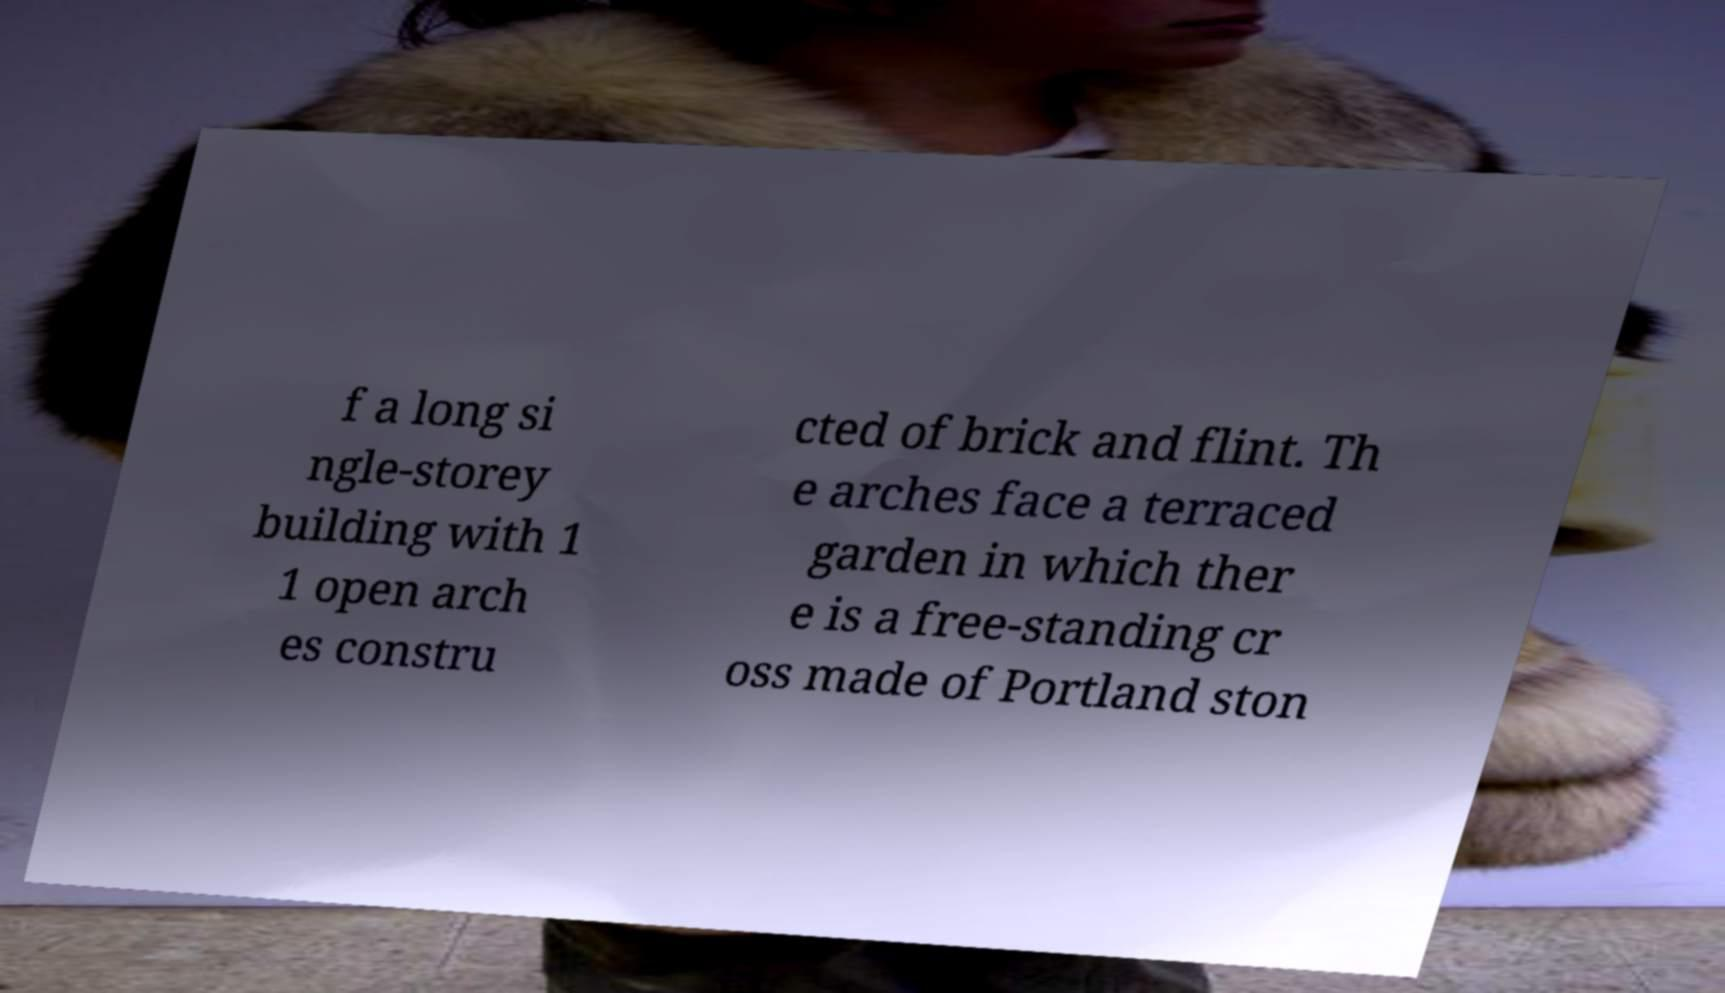There's text embedded in this image that I need extracted. Can you transcribe it verbatim? f a long si ngle-storey building with 1 1 open arch es constru cted of brick and flint. Th e arches face a terraced garden in which ther e is a free-standing cr oss made of Portland ston 